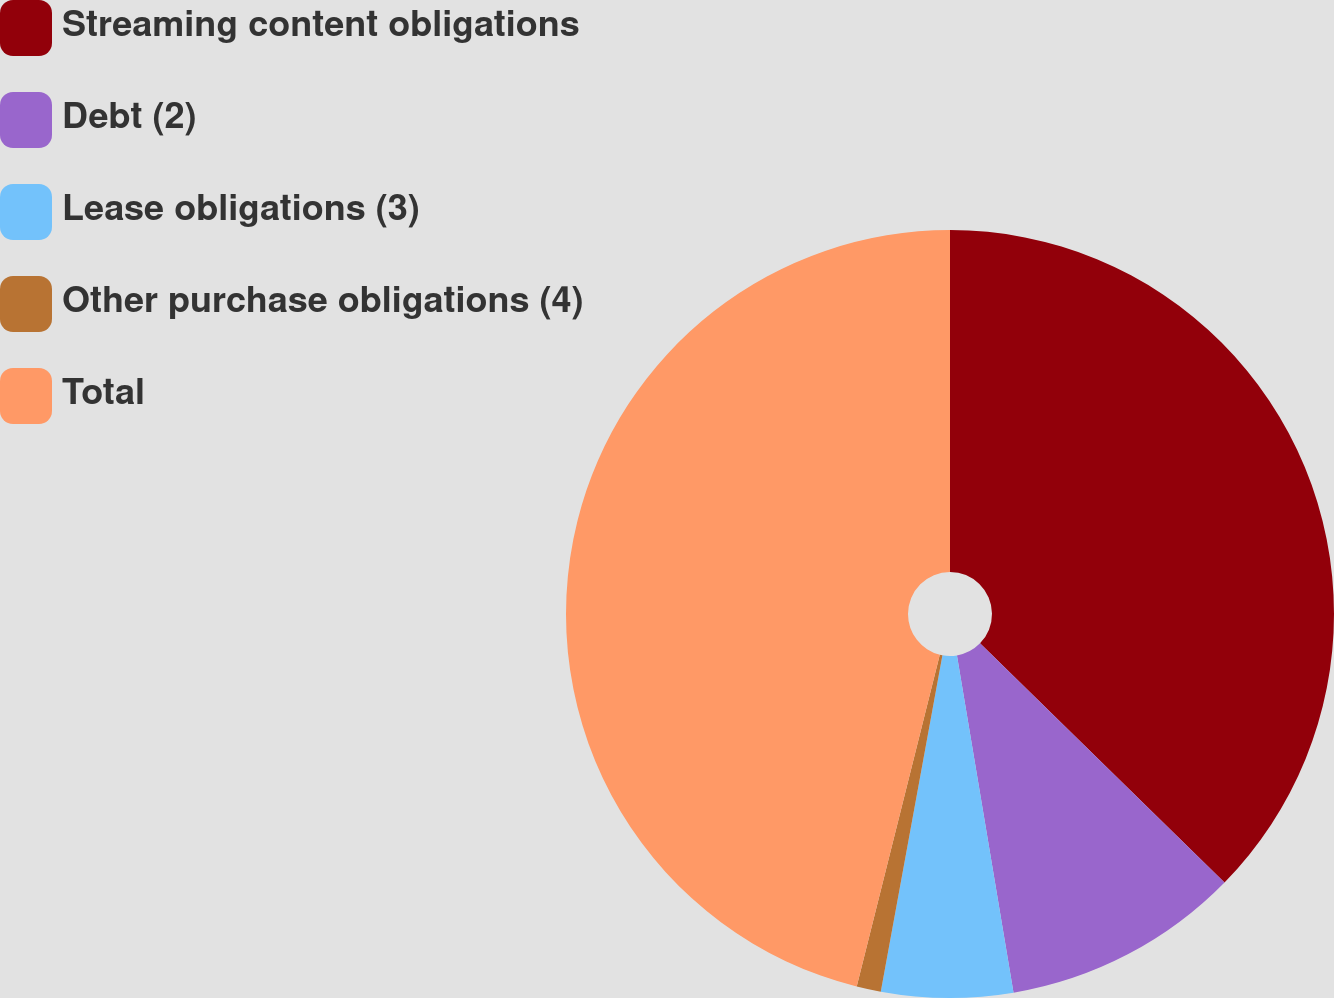<chart> <loc_0><loc_0><loc_500><loc_500><pie_chart><fcel>Streaming content obligations<fcel>Debt (2)<fcel>Lease obligations (3)<fcel>Other purchase obligations (4)<fcel>Total<nl><fcel>37.32%<fcel>10.03%<fcel>5.53%<fcel>1.02%<fcel>46.09%<nl></chart> 